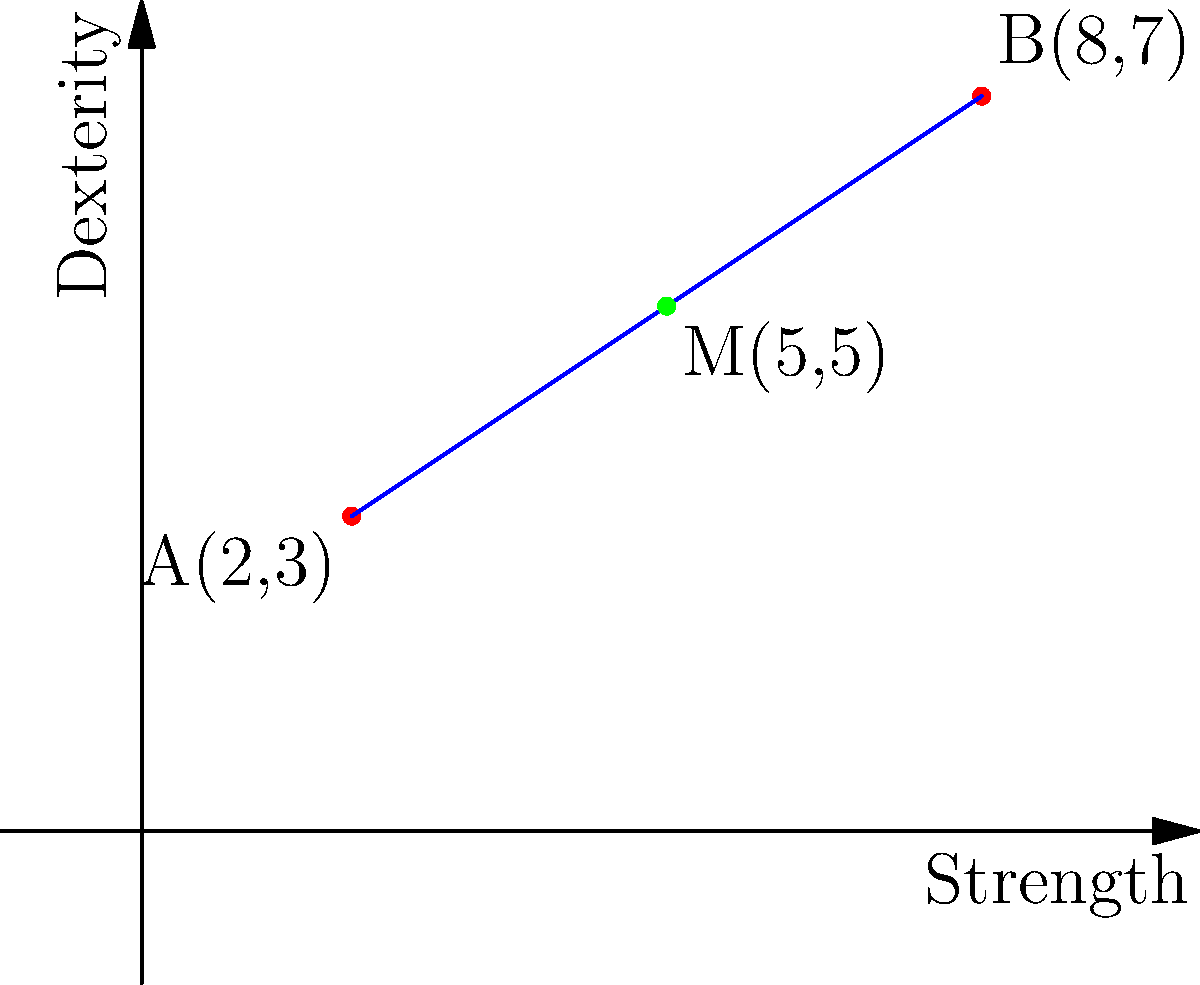In a character stat tracking app, two ability scores are represented as points on a coordinate plane. Point A(2,3) represents the Strength and Dexterity scores of one character, while point B(8,7) represents the same scores for another character. Find the coordinates of the midpoint M of the line segment connecting these two points, which could represent an average character's stats. To find the midpoint of a line segment, we can use the midpoint formula:

$$ M_x = \frac{x_1 + x_2}{2}, M_y = \frac{y_1 + y_2}{2} $$

Where $(x_1, y_1)$ are the coordinates of the first point and $(x_2, y_2)$ are the coordinates of the second point.

Step 1: Identify the coordinates
Point A: $(x_1, y_1) = (2, 3)$
Point B: $(x_2, y_2) = (8, 7)$

Step 2: Calculate the x-coordinate of the midpoint
$M_x = \frac{x_1 + x_2}{2} = \frac{2 + 8}{2} = \frac{10}{2} = 5$

Step 3: Calculate the y-coordinate of the midpoint
$M_y = \frac{y_1 + y_2}{2} = \frac{3 + 7}{2} = \frac{10}{2} = 5$

Step 4: Combine the results
The midpoint M has coordinates $(M_x, M_y) = (5, 5)$
Answer: (5, 5) 